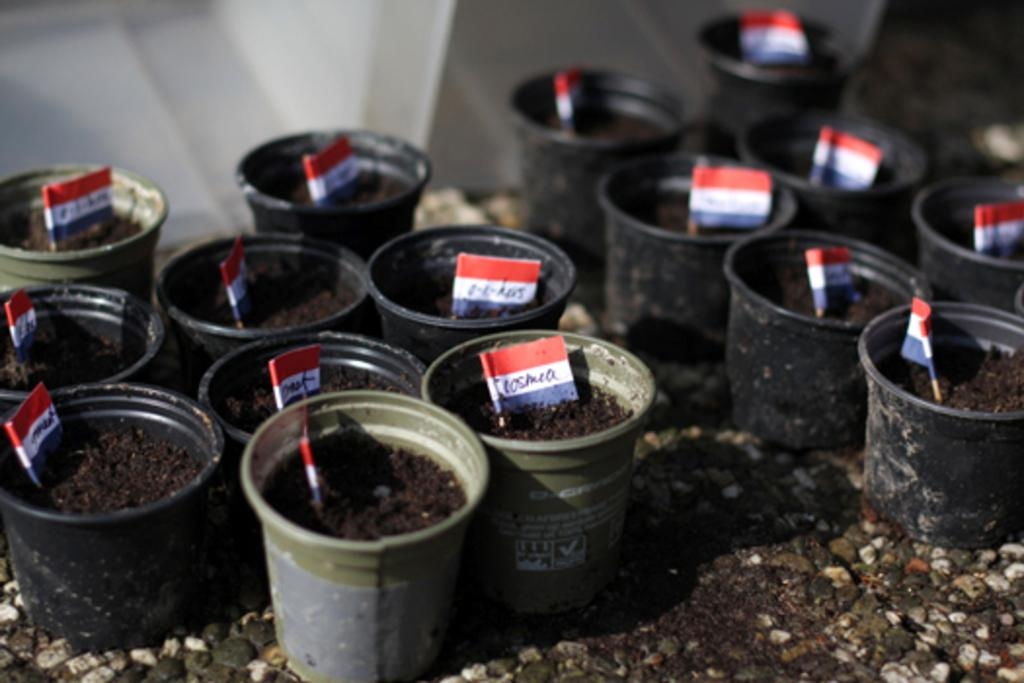What colors are the pots in the image? The pots in the image are black and green. What is kept inside the pots? Paper flags are kept in the pots. What type of jeans is the servant wearing in the image? There is no servant or jeans present in the image. The image only features black and green color pots with paper flags inside them. 